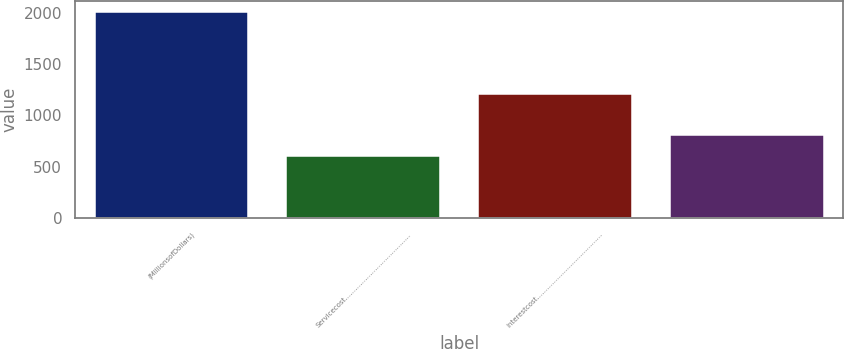Convert chart. <chart><loc_0><loc_0><loc_500><loc_500><bar_chart><fcel>(MillionsofDollars)<fcel>Servicecost…………………………………<fcel>Interestcost…………………………………<fcel>Unnamed: 3<nl><fcel>2010<fcel>603.14<fcel>1206.08<fcel>804.12<nl></chart> 